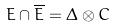<formula> <loc_0><loc_0><loc_500><loc_500>E \cap \overline { E } = \Delta \otimes C</formula> 